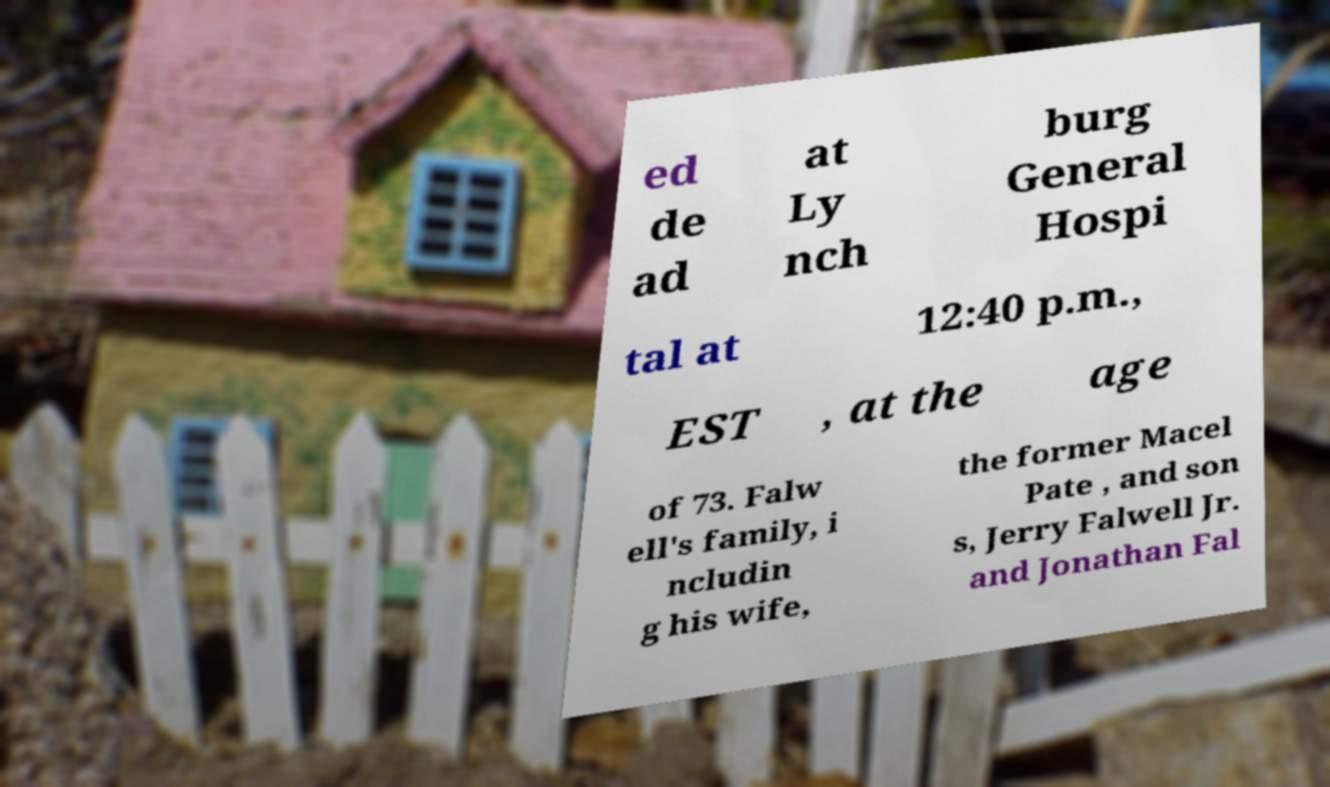For documentation purposes, I need the text within this image transcribed. Could you provide that? ed de ad at Ly nch burg General Hospi tal at 12:40 p.m., EST , at the age of 73. Falw ell's family, i ncludin g his wife, the former Macel Pate , and son s, Jerry Falwell Jr. and Jonathan Fal 